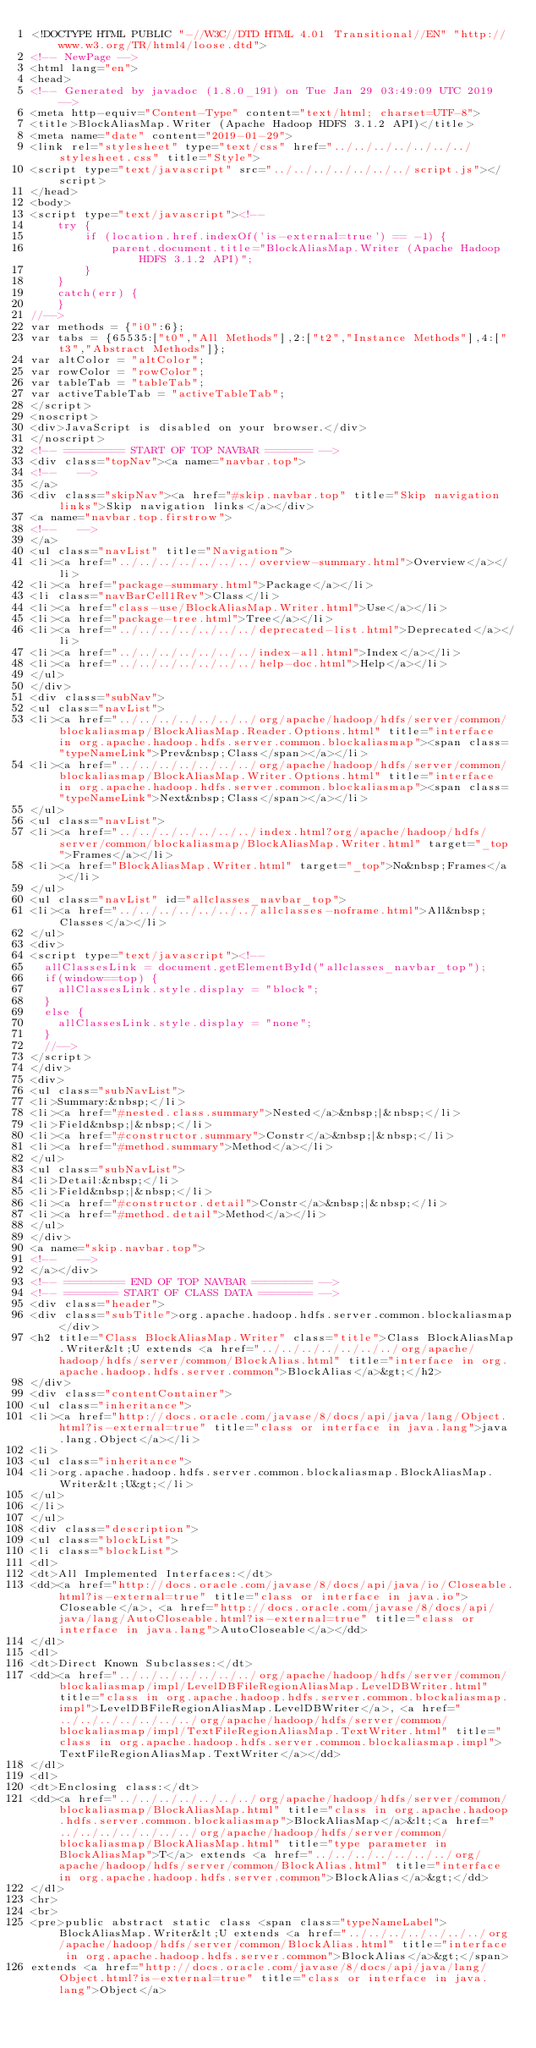<code> <loc_0><loc_0><loc_500><loc_500><_HTML_><!DOCTYPE HTML PUBLIC "-//W3C//DTD HTML 4.01 Transitional//EN" "http://www.w3.org/TR/html4/loose.dtd">
<!-- NewPage -->
<html lang="en">
<head>
<!-- Generated by javadoc (1.8.0_191) on Tue Jan 29 03:49:09 UTC 2019 -->
<meta http-equiv="Content-Type" content="text/html; charset=UTF-8">
<title>BlockAliasMap.Writer (Apache Hadoop HDFS 3.1.2 API)</title>
<meta name="date" content="2019-01-29">
<link rel="stylesheet" type="text/css" href="../../../../../../../stylesheet.css" title="Style">
<script type="text/javascript" src="../../../../../../../script.js"></script>
</head>
<body>
<script type="text/javascript"><!--
    try {
        if (location.href.indexOf('is-external=true') == -1) {
            parent.document.title="BlockAliasMap.Writer (Apache Hadoop HDFS 3.1.2 API)";
        }
    }
    catch(err) {
    }
//-->
var methods = {"i0":6};
var tabs = {65535:["t0","All Methods"],2:["t2","Instance Methods"],4:["t3","Abstract Methods"]};
var altColor = "altColor";
var rowColor = "rowColor";
var tableTab = "tableTab";
var activeTableTab = "activeTableTab";
</script>
<noscript>
<div>JavaScript is disabled on your browser.</div>
</noscript>
<!-- ========= START OF TOP NAVBAR ======= -->
<div class="topNav"><a name="navbar.top">
<!--   -->
</a>
<div class="skipNav"><a href="#skip.navbar.top" title="Skip navigation links">Skip navigation links</a></div>
<a name="navbar.top.firstrow">
<!--   -->
</a>
<ul class="navList" title="Navigation">
<li><a href="../../../../../../../overview-summary.html">Overview</a></li>
<li><a href="package-summary.html">Package</a></li>
<li class="navBarCell1Rev">Class</li>
<li><a href="class-use/BlockAliasMap.Writer.html">Use</a></li>
<li><a href="package-tree.html">Tree</a></li>
<li><a href="../../../../../../../deprecated-list.html">Deprecated</a></li>
<li><a href="../../../../../../../index-all.html">Index</a></li>
<li><a href="../../../../../../../help-doc.html">Help</a></li>
</ul>
</div>
<div class="subNav">
<ul class="navList">
<li><a href="../../../../../../../org/apache/hadoop/hdfs/server/common/blockaliasmap/BlockAliasMap.Reader.Options.html" title="interface in org.apache.hadoop.hdfs.server.common.blockaliasmap"><span class="typeNameLink">Prev&nbsp;Class</span></a></li>
<li><a href="../../../../../../../org/apache/hadoop/hdfs/server/common/blockaliasmap/BlockAliasMap.Writer.Options.html" title="interface in org.apache.hadoop.hdfs.server.common.blockaliasmap"><span class="typeNameLink">Next&nbsp;Class</span></a></li>
</ul>
<ul class="navList">
<li><a href="../../../../../../../index.html?org/apache/hadoop/hdfs/server/common/blockaliasmap/BlockAliasMap.Writer.html" target="_top">Frames</a></li>
<li><a href="BlockAliasMap.Writer.html" target="_top">No&nbsp;Frames</a></li>
</ul>
<ul class="navList" id="allclasses_navbar_top">
<li><a href="../../../../../../../allclasses-noframe.html">All&nbsp;Classes</a></li>
</ul>
<div>
<script type="text/javascript"><!--
  allClassesLink = document.getElementById("allclasses_navbar_top");
  if(window==top) {
    allClassesLink.style.display = "block";
  }
  else {
    allClassesLink.style.display = "none";
  }
  //-->
</script>
</div>
<div>
<ul class="subNavList">
<li>Summary:&nbsp;</li>
<li><a href="#nested.class.summary">Nested</a>&nbsp;|&nbsp;</li>
<li>Field&nbsp;|&nbsp;</li>
<li><a href="#constructor.summary">Constr</a>&nbsp;|&nbsp;</li>
<li><a href="#method.summary">Method</a></li>
</ul>
<ul class="subNavList">
<li>Detail:&nbsp;</li>
<li>Field&nbsp;|&nbsp;</li>
<li><a href="#constructor.detail">Constr</a>&nbsp;|&nbsp;</li>
<li><a href="#method.detail">Method</a></li>
</ul>
</div>
<a name="skip.navbar.top">
<!--   -->
</a></div>
<!-- ========= END OF TOP NAVBAR ========= -->
<!-- ======== START OF CLASS DATA ======== -->
<div class="header">
<div class="subTitle">org.apache.hadoop.hdfs.server.common.blockaliasmap</div>
<h2 title="Class BlockAliasMap.Writer" class="title">Class BlockAliasMap.Writer&lt;U extends <a href="../../../../../../../org/apache/hadoop/hdfs/server/common/BlockAlias.html" title="interface in org.apache.hadoop.hdfs.server.common">BlockAlias</a>&gt;</h2>
</div>
<div class="contentContainer">
<ul class="inheritance">
<li><a href="http://docs.oracle.com/javase/8/docs/api/java/lang/Object.html?is-external=true" title="class or interface in java.lang">java.lang.Object</a></li>
<li>
<ul class="inheritance">
<li>org.apache.hadoop.hdfs.server.common.blockaliasmap.BlockAliasMap.Writer&lt;U&gt;</li>
</ul>
</li>
</ul>
<div class="description">
<ul class="blockList">
<li class="blockList">
<dl>
<dt>All Implemented Interfaces:</dt>
<dd><a href="http://docs.oracle.com/javase/8/docs/api/java/io/Closeable.html?is-external=true" title="class or interface in java.io">Closeable</a>, <a href="http://docs.oracle.com/javase/8/docs/api/java/lang/AutoCloseable.html?is-external=true" title="class or interface in java.lang">AutoCloseable</a></dd>
</dl>
<dl>
<dt>Direct Known Subclasses:</dt>
<dd><a href="../../../../../../../org/apache/hadoop/hdfs/server/common/blockaliasmap/impl/LevelDBFileRegionAliasMap.LevelDBWriter.html" title="class in org.apache.hadoop.hdfs.server.common.blockaliasmap.impl">LevelDBFileRegionAliasMap.LevelDBWriter</a>, <a href="../../../../../../../org/apache/hadoop/hdfs/server/common/blockaliasmap/impl/TextFileRegionAliasMap.TextWriter.html" title="class in org.apache.hadoop.hdfs.server.common.blockaliasmap.impl">TextFileRegionAliasMap.TextWriter</a></dd>
</dl>
<dl>
<dt>Enclosing class:</dt>
<dd><a href="../../../../../../../org/apache/hadoop/hdfs/server/common/blockaliasmap/BlockAliasMap.html" title="class in org.apache.hadoop.hdfs.server.common.blockaliasmap">BlockAliasMap</a>&lt;<a href="../../../../../../../org/apache/hadoop/hdfs/server/common/blockaliasmap/BlockAliasMap.html" title="type parameter in BlockAliasMap">T</a> extends <a href="../../../../../../../org/apache/hadoop/hdfs/server/common/BlockAlias.html" title="interface in org.apache.hadoop.hdfs.server.common">BlockAlias</a>&gt;</dd>
</dl>
<hr>
<br>
<pre>public abstract static class <span class="typeNameLabel">BlockAliasMap.Writer&lt;U extends <a href="../../../../../../../org/apache/hadoop/hdfs/server/common/BlockAlias.html" title="interface in org.apache.hadoop.hdfs.server.common">BlockAlias</a>&gt;</span>
extends <a href="http://docs.oracle.com/javase/8/docs/api/java/lang/Object.html?is-external=true" title="class or interface in java.lang">Object</a></code> 